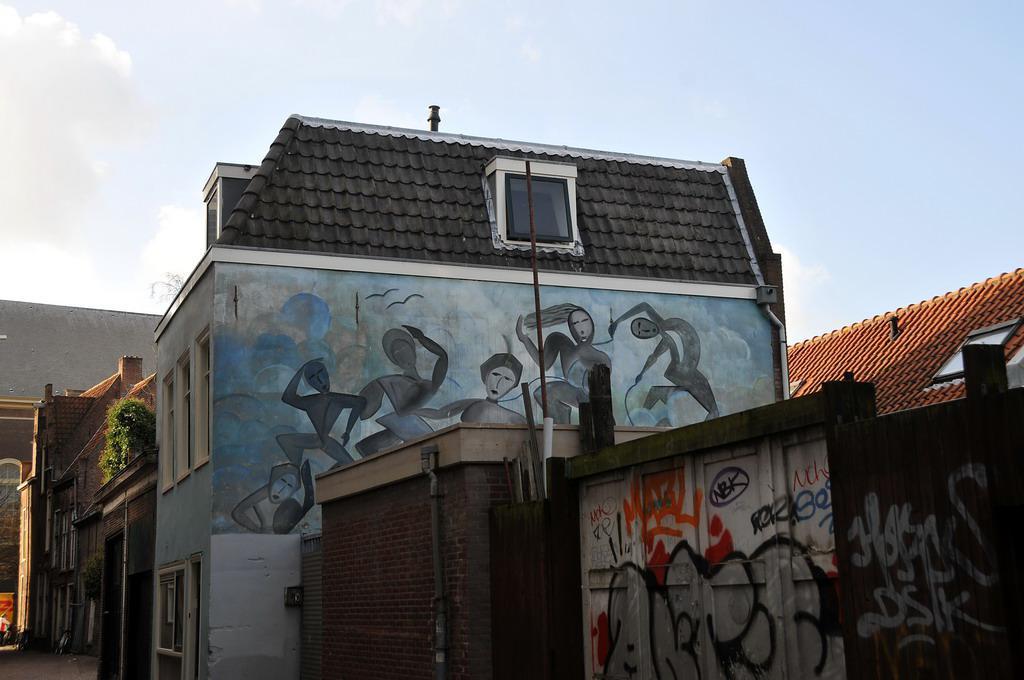In one or two sentences, can you explain what this image depicts? In this picture we can see some text and other things on the objects. We can see a painting of a few people, birds and a few things on a house. There are buildings, plants and other objects. We can see the clouds in the sky. 